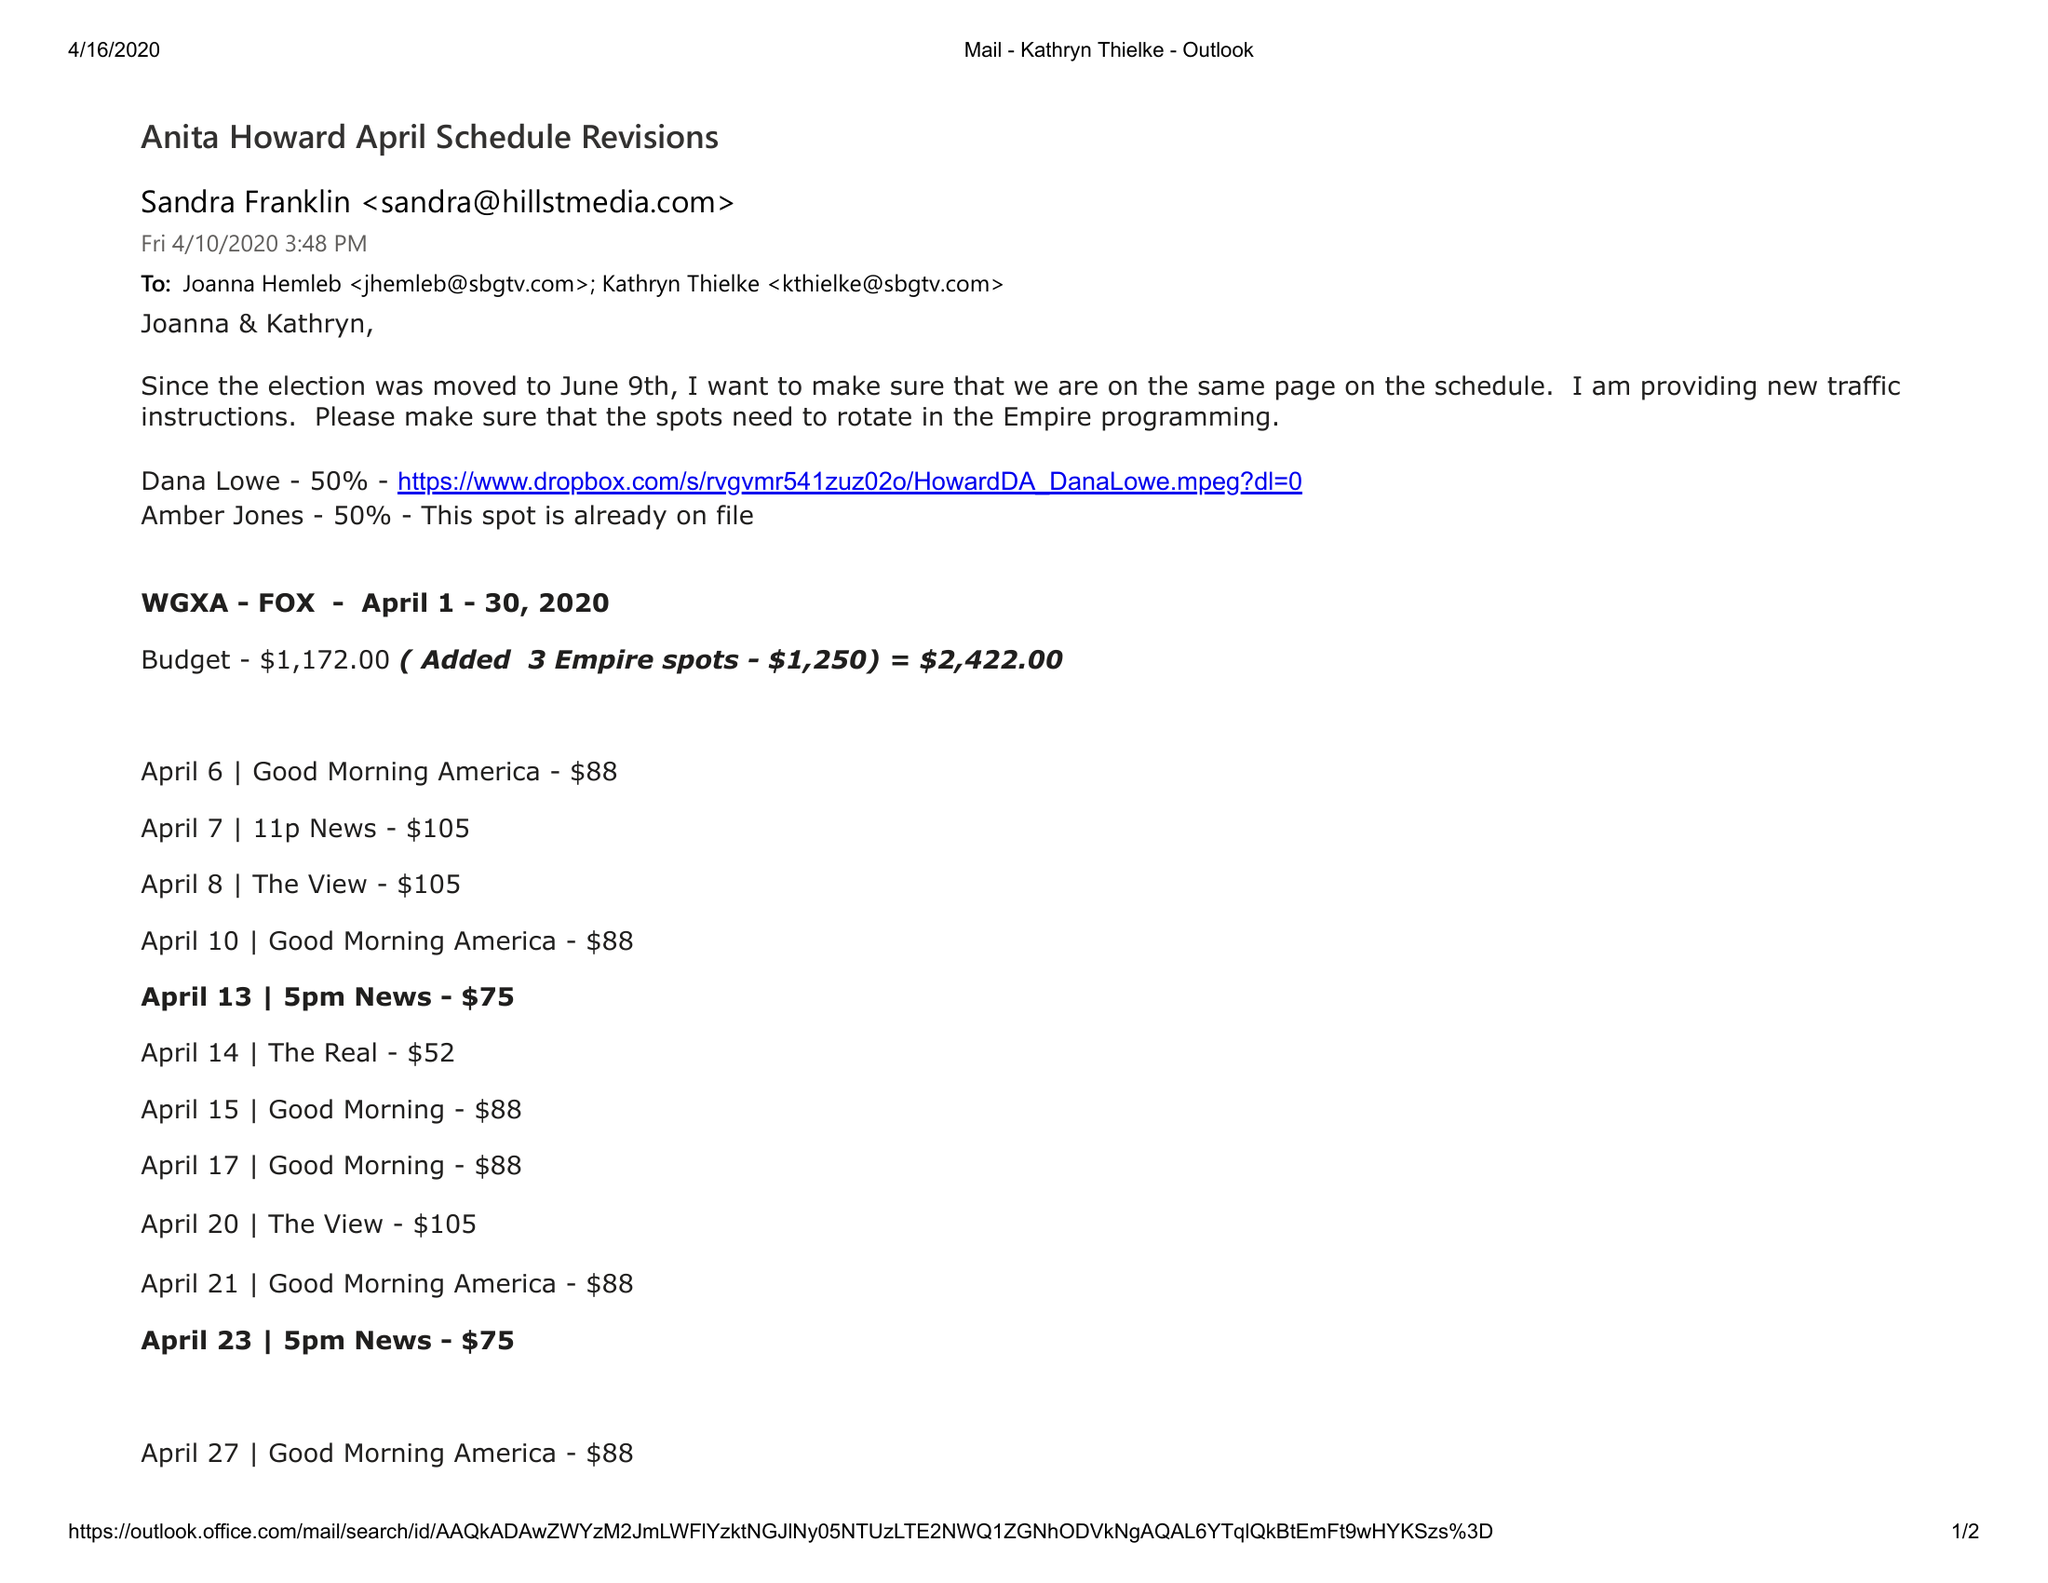What is the value for the advertiser?
Answer the question using a single word or phrase. None 